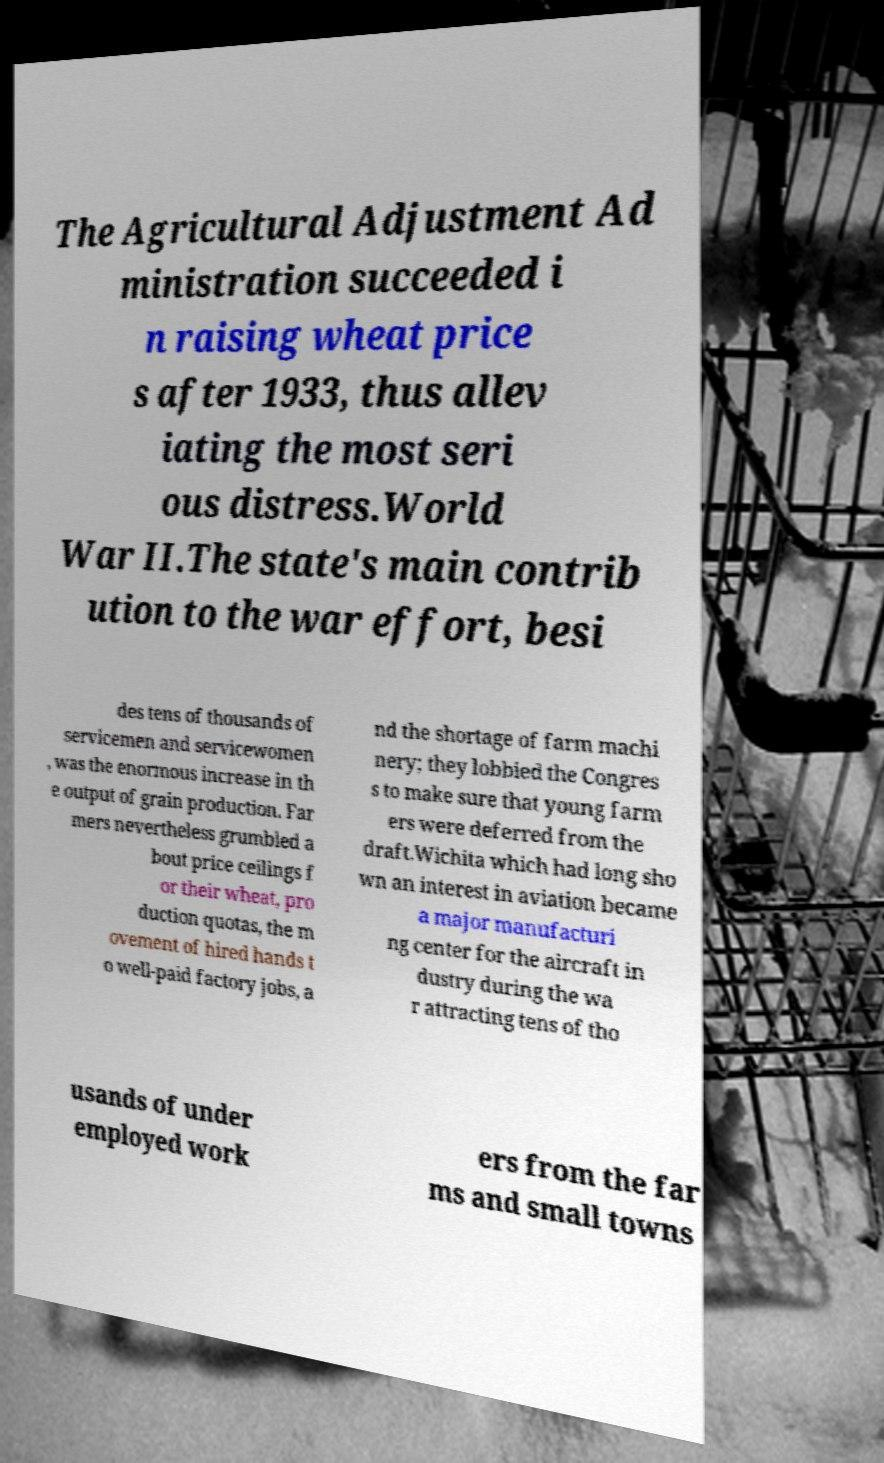For documentation purposes, I need the text within this image transcribed. Could you provide that? The Agricultural Adjustment Ad ministration succeeded i n raising wheat price s after 1933, thus allev iating the most seri ous distress.World War II.The state's main contrib ution to the war effort, besi des tens of thousands of servicemen and servicewomen , was the enormous increase in th e output of grain production. Far mers nevertheless grumbled a bout price ceilings f or their wheat, pro duction quotas, the m ovement of hired hands t o well-paid factory jobs, a nd the shortage of farm machi nery; they lobbied the Congres s to make sure that young farm ers were deferred from the draft.Wichita which had long sho wn an interest in aviation became a major manufacturi ng center for the aircraft in dustry during the wa r attracting tens of tho usands of under employed work ers from the far ms and small towns 